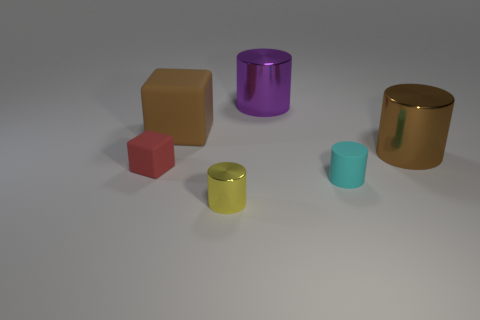Subtract all cyan cylinders. How many cylinders are left? 3 Subtract all purple cylinders. How many cylinders are left? 3 Add 2 big metallic cylinders. How many objects exist? 8 Subtract all red cylinders. Subtract all gray cubes. How many cylinders are left? 4 Subtract all blocks. How many objects are left? 4 Subtract 0 gray cylinders. How many objects are left? 6 Subtract all brown cylinders. Subtract all brown rubber cubes. How many objects are left? 4 Add 6 small yellow objects. How many small yellow objects are left? 7 Add 1 large purple cylinders. How many large purple cylinders exist? 2 